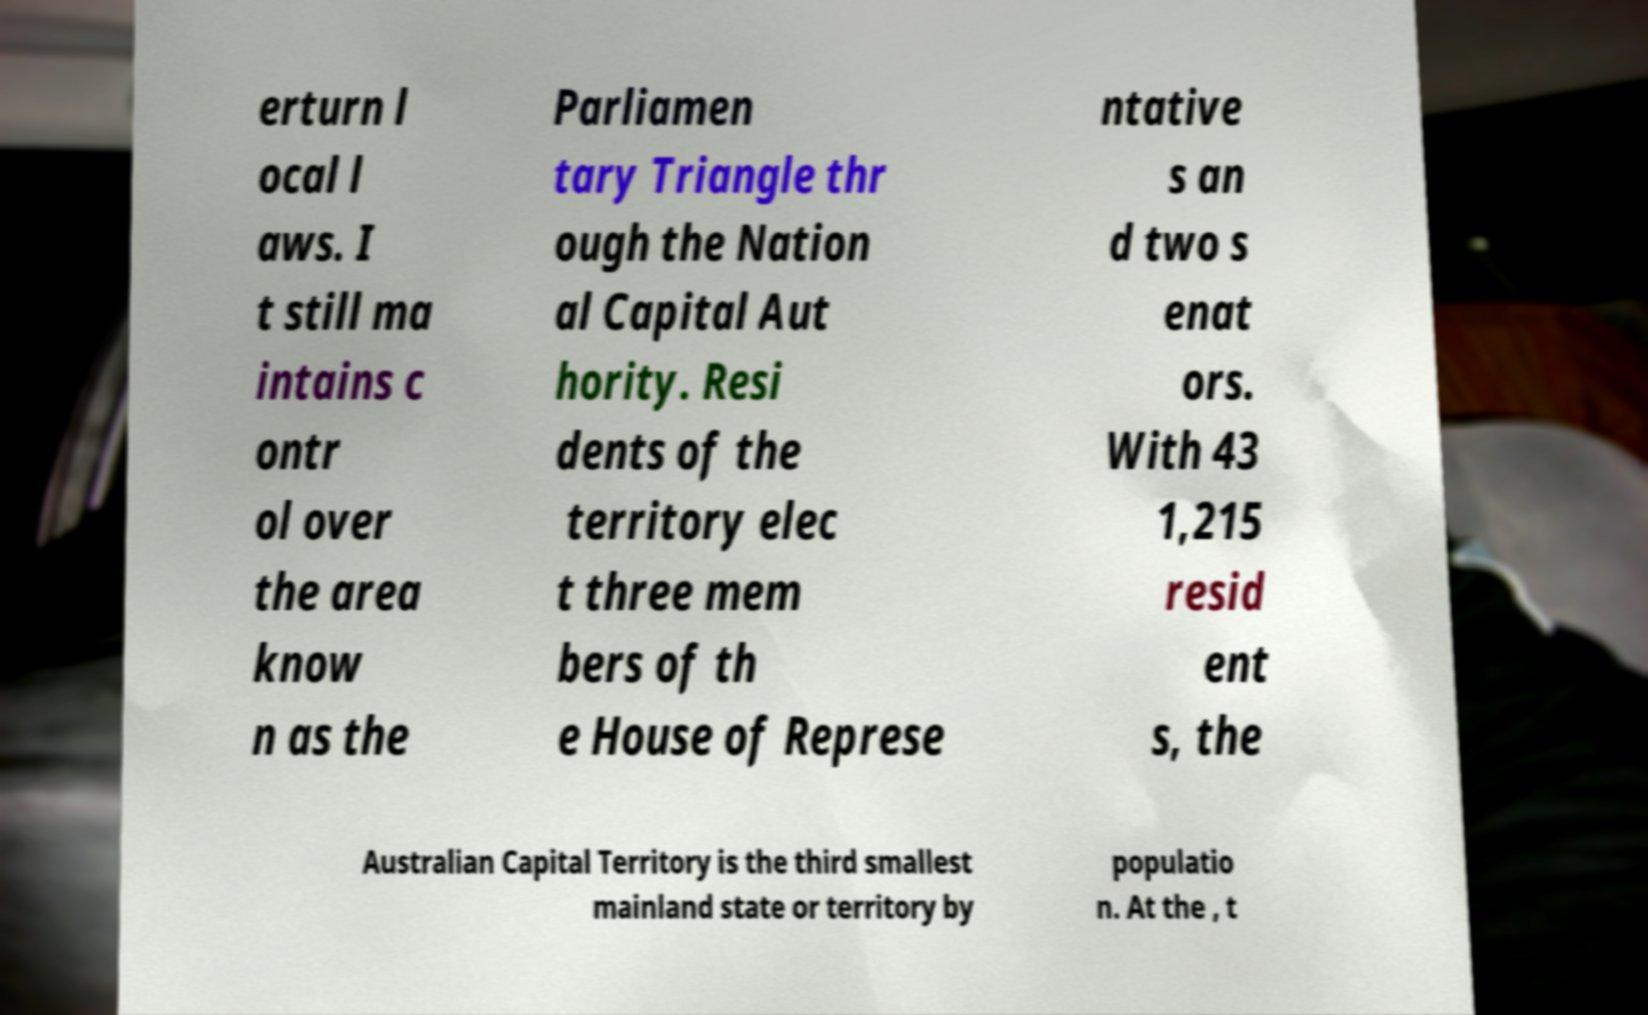What messages or text are displayed in this image? I need them in a readable, typed format. erturn l ocal l aws. I t still ma intains c ontr ol over the area know n as the Parliamen tary Triangle thr ough the Nation al Capital Aut hority. Resi dents of the territory elec t three mem bers of th e House of Represe ntative s an d two s enat ors. With 43 1,215 resid ent s, the Australian Capital Territory is the third smallest mainland state or territory by populatio n. At the , t 